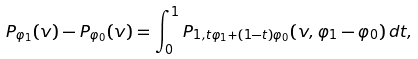Convert formula to latex. <formula><loc_0><loc_0><loc_500><loc_500>P _ { \varphi _ { 1 } } ( v ) - P _ { \varphi _ { 0 } } ( v ) = \int _ { 0 } ^ { 1 } P _ { 1 , t \varphi _ { 1 } + ( 1 - t ) \varphi _ { 0 } } ( v , \varphi _ { 1 } - \varphi _ { 0 } ) \, d t ,</formula> 